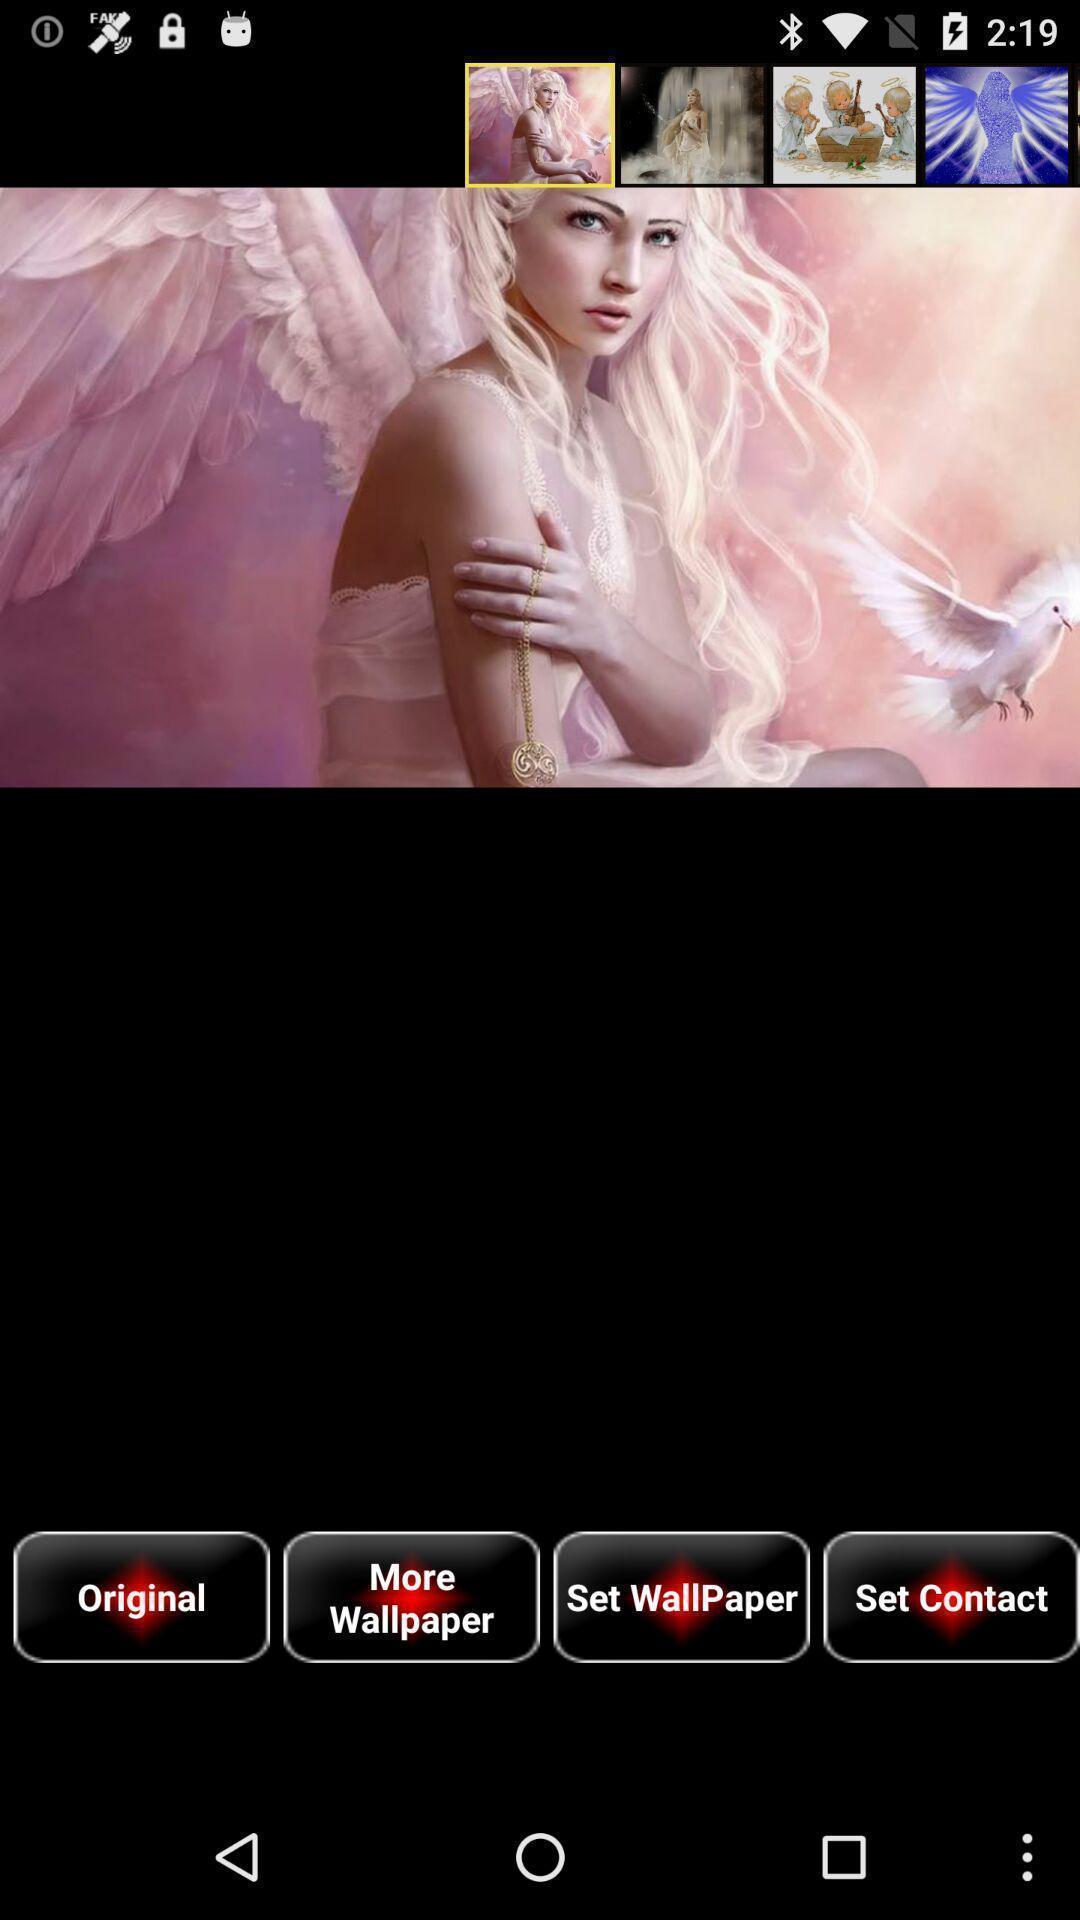What is the overall content of this screenshot? Page displaying image with other options. 